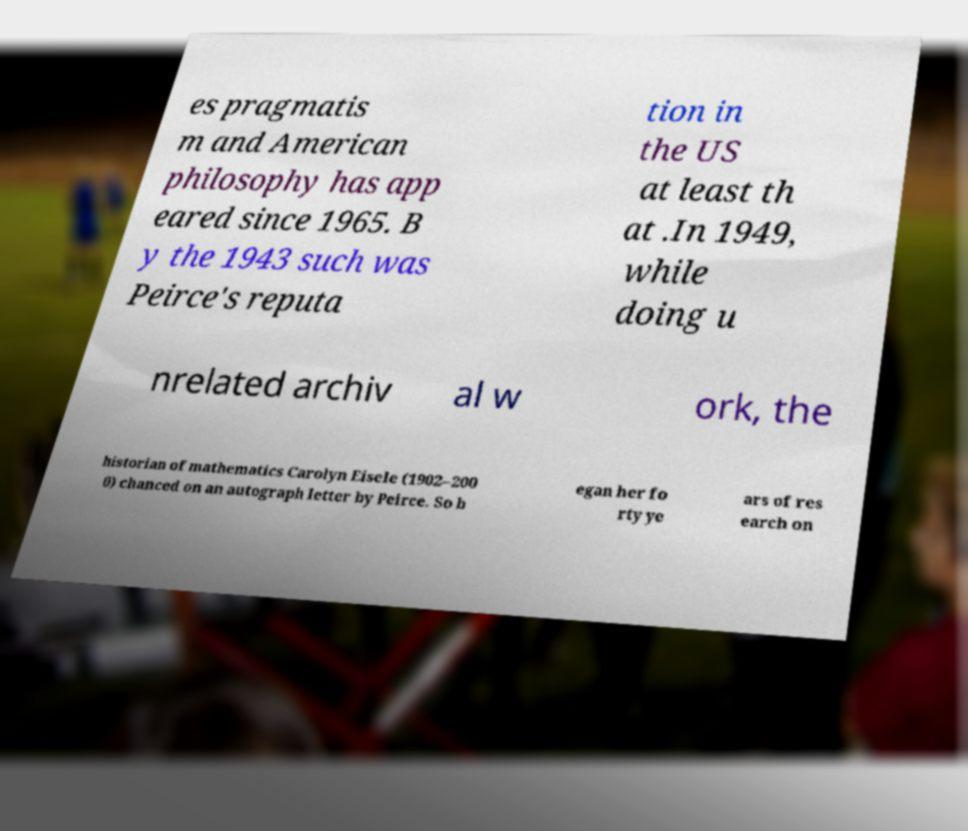There's text embedded in this image that I need extracted. Can you transcribe it verbatim? es pragmatis m and American philosophy has app eared since 1965. B y the 1943 such was Peirce's reputa tion in the US at least th at .In 1949, while doing u nrelated archiv al w ork, the historian of mathematics Carolyn Eisele (1902–200 0) chanced on an autograph letter by Peirce. So b egan her fo rty ye ars of res earch on 